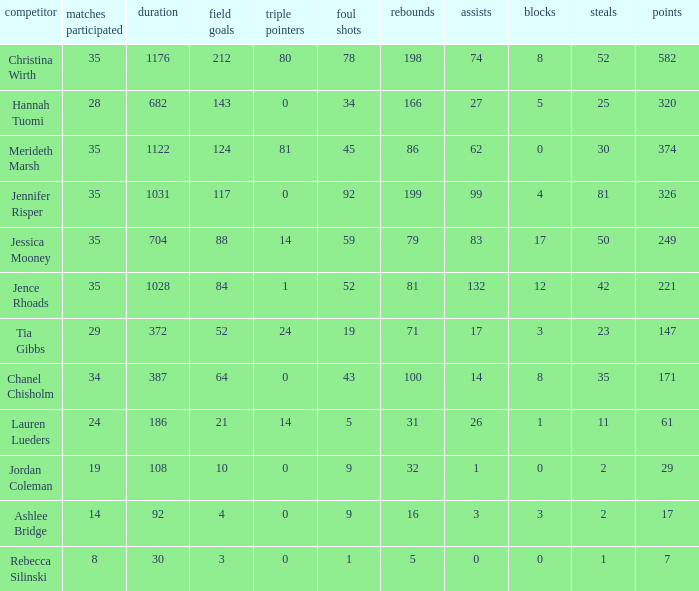How many blockings occured in the game with 198 rebounds? 8.0. 